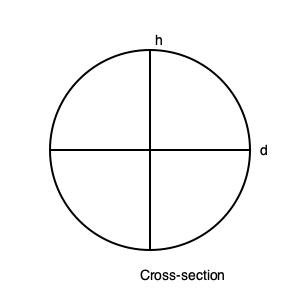Hey cylinder enthusiasts! Our favorite co-host just rolled a massive can of laughs across the stage. If the diameter of this cylindrical can of comedy is 8 inches and its height is 12 inches, what's the volume of hilarity contained within? Don't forget to use π = 3.14 and round your answer to the nearest cubic inch! Alright, let's break this down step-by-step:

1) The formula for the volume of a cylinder is:
   $V = πr^2h$
   where $V$ is volume, $r$ is radius, and $h$ is height.

2) We're given the diameter (d) of 8 inches. The radius is half of this:
   $r = d/2 = 8/2 = 4$ inches

3) The height (h) is given as 12 inches.

4) Now let's plug these into our formula:
   $V = π(4^2)(12)$

5) Simplify the exponent:
   $V = π(16)(12)$

6) Multiply:
   $V = π(192)$

7) Use the given value of π (3.14):
   $V = 3.14(192)$

8) Calculate:
   $V = 602.88$ cubic inches

9) Rounding to the nearest cubic inch:
   $V ≈ 603$ cubic inches

And there you have it! That's one voluminous can of laughter!
Answer: 603 cubic inches 